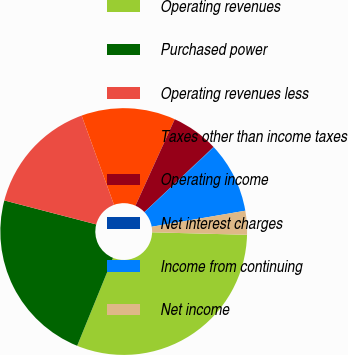<chart> <loc_0><loc_0><loc_500><loc_500><pie_chart><fcel>Operating revenues<fcel>Purchased power<fcel>Operating revenues less<fcel>Taxes other than income taxes<fcel>Operating income<fcel>Net interest charges<fcel>Income from continuing<fcel>Net income<nl><fcel>30.74%<fcel>22.9%<fcel>15.4%<fcel>12.33%<fcel>6.19%<fcel>0.06%<fcel>9.26%<fcel>3.12%<nl></chart> 